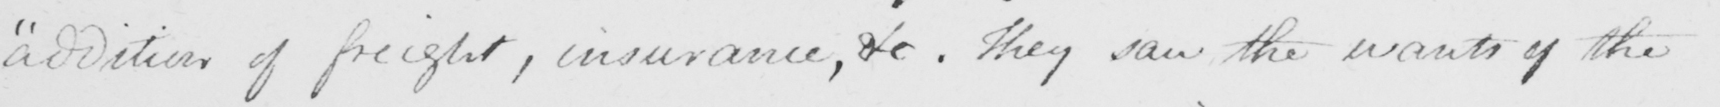What is written in this line of handwriting? addition of freight , insurance , &c . They saw the wants of the 